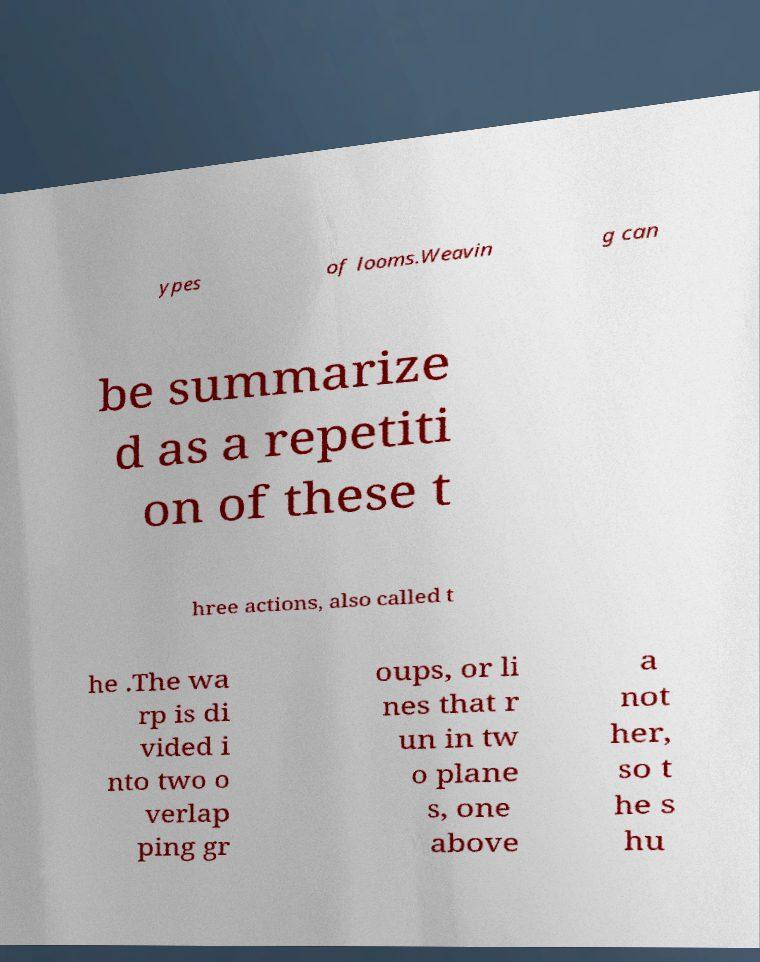Please identify and transcribe the text found in this image. ypes of looms.Weavin g can be summarize d as a repetiti on of these t hree actions, also called t he .The wa rp is di vided i nto two o verlap ping gr oups, or li nes that r un in tw o plane s, one above a not her, so t he s hu 